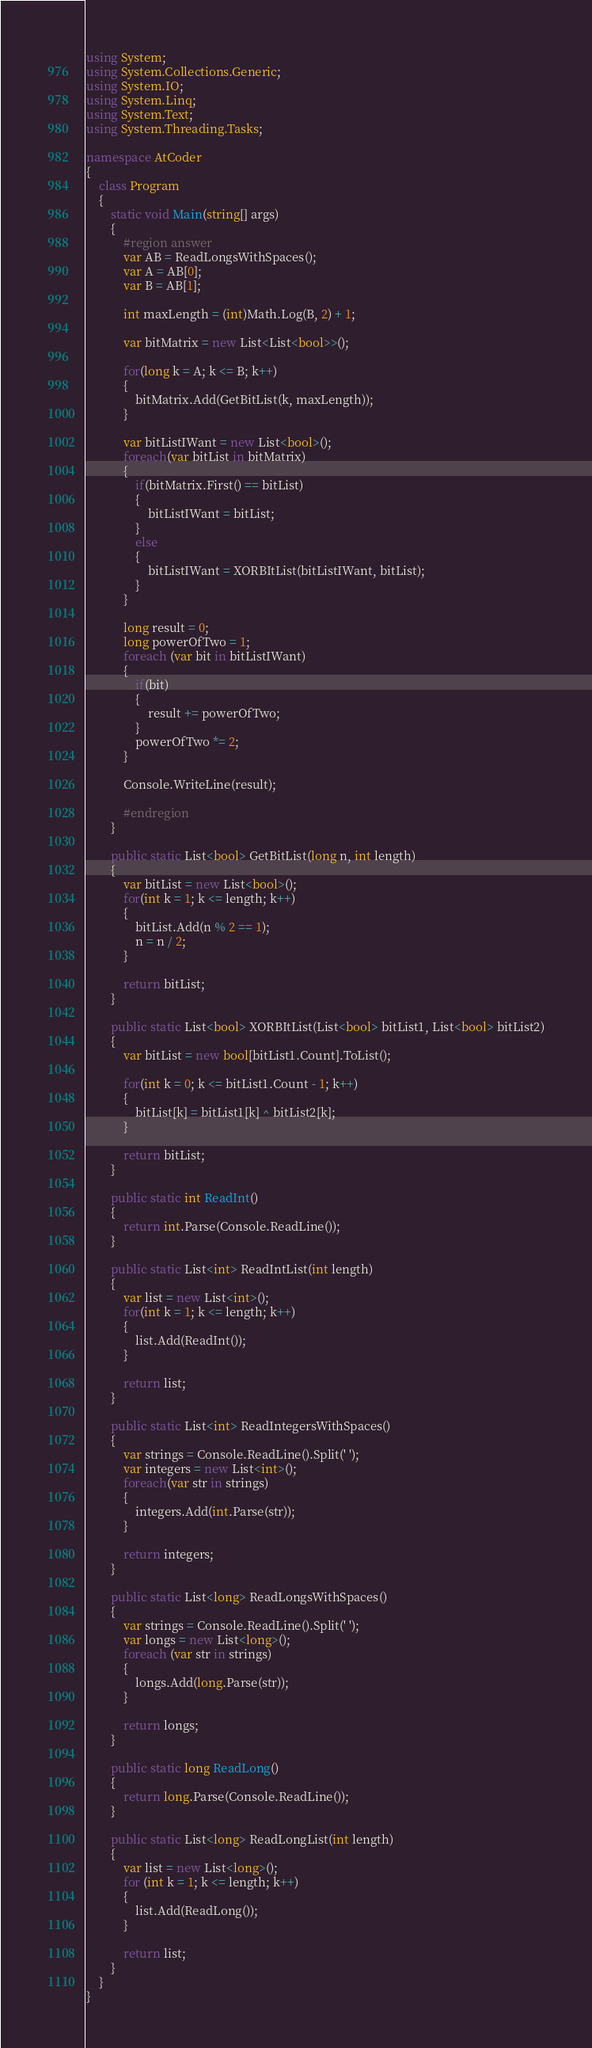<code> <loc_0><loc_0><loc_500><loc_500><_C#_>using System;
using System.Collections.Generic;
using System.IO;
using System.Linq;
using System.Text;
using System.Threading.Tasks;

namespace AtCoder
{
    class Program
    {
        static void Main(string[] args)
        {
            #region answer
            var AB = ReadLongsWithSpaces();
            var A = AB[0];
            var B = AB[1];

            int maxLength = (int)Math.Log(B, 2) + 1;

            var bitMatrix = new List<List<bool>>();

            for(long k = A; k <= B; k++)
            {
                bitMatrix.Add(GetBitList(k, maxLength));
            }

            var bitListIWant = new List<bool>();
            foreach(var bitList in bitMatrix)
            {
                if(bitMatrix.First() == bitList)
                {
                    bitListIWant = bitList;
                }
                else
                {
                    bitListIWant = XORBItList(bitListIWant, bitList);
                }
            }

            long result = 0;
            long powerOfTwo = 1;
            foreach (var bit in bitListIWant)
            {
                if(bit)
                {
                    result += powerOfTwo;
                }
                powerOfTwo *= 2;
            }

            Console.WriteLine(result);

            #endregion
        }

        public static List<bool> GetBitList(long n, int length)
        {
            var bitList = new List<bool>();
            for(int k = 1; k <= length; k++)
            {
                bitList.Add(n % 2 == 1);
                n = n / 2;
            }

            return bitList;
        }

        public static List<bool> XORBItList(List<bool> bitList1, List<bool> bitList2)
        {
            var bitList = new bool[bitList1.Count].ToList();

            for(int k = 0; k <= bitList1.Count - 1; k++)
            {
                bitList[k] = bitList1[k] ^ bitList2[k];
            }

            return bitList;
        }

        public static int ReadInt()
        {
            return int.Parse(Console.ReadLine());
        }

        public static List<int> ReadIntList(int length)
        {
            var list = new List<int>();
            for(int k = 1; k <= length; k++)
            {
                list.Add(ReadInt());
            }

            return list;
        }

        public static List<int> ReadIntegersWithSpaces()
        {
            var strings = Console.ReadLine().Split(' ');
            var integers = new List<int>();
            foreach(var str in strings)
            {
                integers.Add(int.Parse(str));
            }

            return integers;
        }

        public static List<long> ReadLongsWithSpaces()
        {
            var strings = Console.ReadLine().Split(' ');
            var longs = new List<long>();
            foreach (var str in strings)
            {
                longs.Add(long.Parse(str));
            }

            return longs;
        }

        public static long ReadLong()
        {
            return long.Parse(Console.ReadLine());
        }

        public static List<long> ReadLongList(int length)
        {
            var list = new List<long>();
            for (int k = 1; k <= length; k++)
            {
                list.Add(ReadLong());
            }

            return list;
        }
    }
}
</code> 